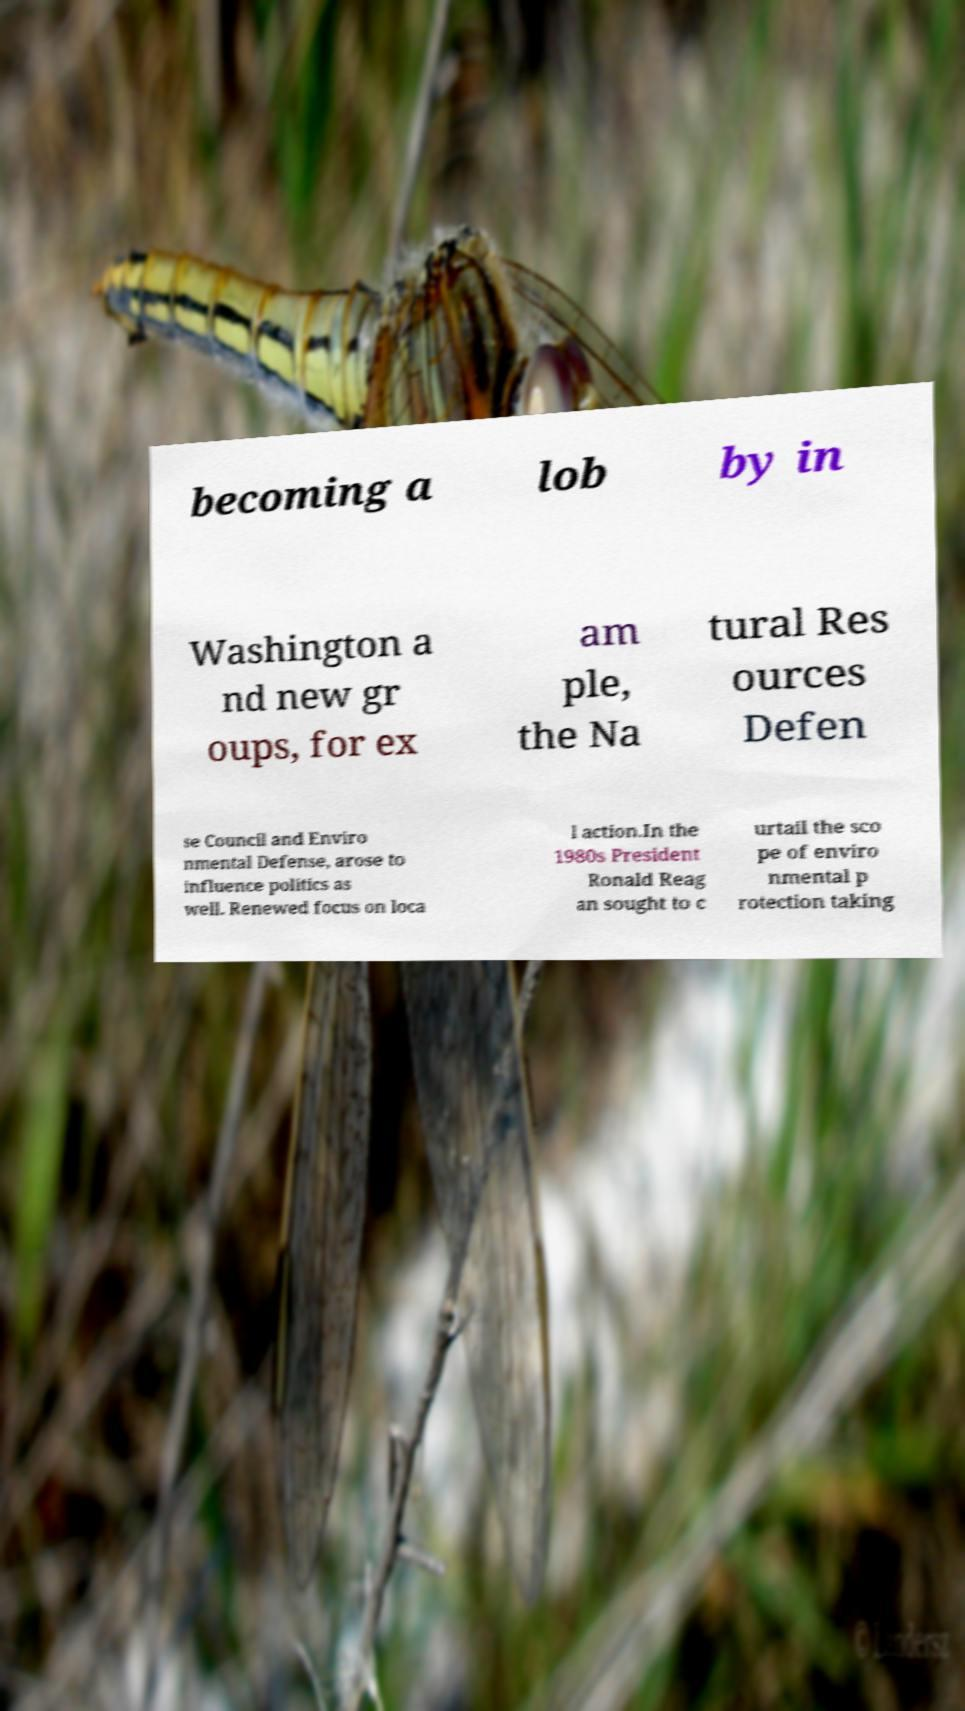Could you extract and type out the text from this image? becoming a lob by in Washington a nd new gr oups, for ex am ple, the Na tural Res ources Defen se Council and Enviro nmental Defense, arose to influence politics as well. Renewed focus on loca l action.In the 1980s President Ronald Reag an sought to c urtail the sco pe of enviro nmental p rotection taking 